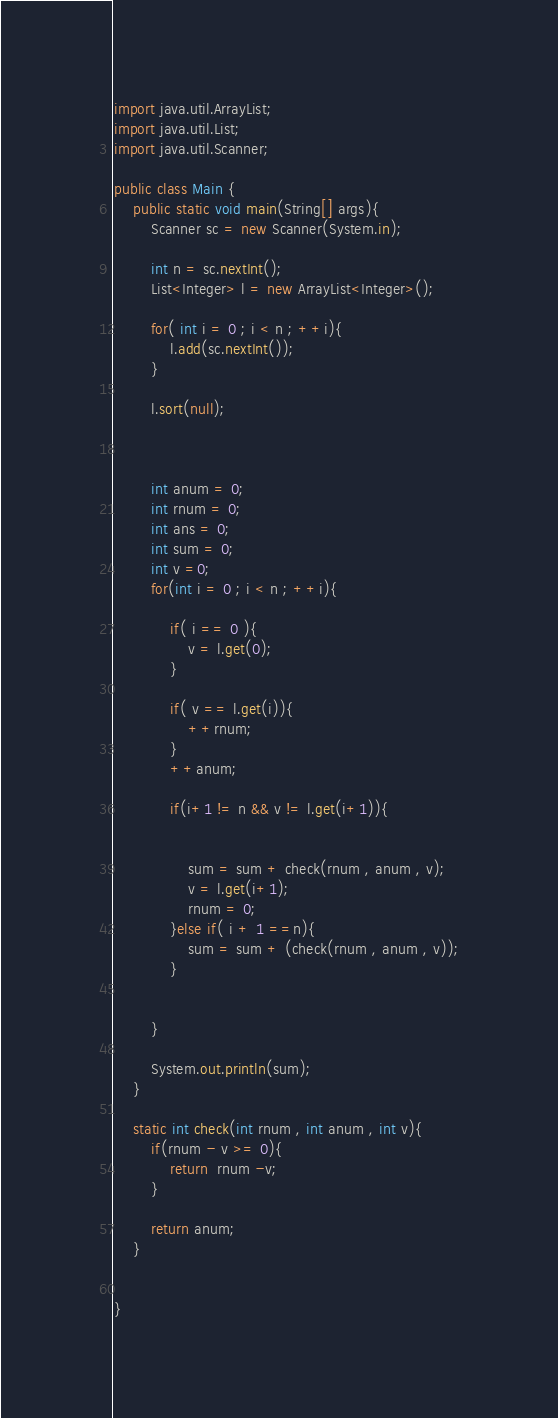<code> <loc_0><loc_0><loc_500><loc_500><_Java_>import java.util.ArrayList;
import java.util.List;
import java.util.Scanner;

public class Main {
	public static void main(String[] args){
		Scanner sc = new Scanner(System.in);

		int n = sc.nextInt();
		List<Integer> l = new ArrayList<Integer>();

		for( int i = 0 ; i < n ; ++i){
			l.add(sc.nextInt());
		}

		l.sort(null);



		int anum = 0;
		int rnum = 0;
		int ans = 0;
		int sum = 0;
		int v =0;
		for(int i = 0 ; i < n ; ++i){

			if( i == 0 ){
				v = l.get(0);
			}

			if( v == l.get(i)){
				++rnum;
			}
			++anum;

			if(i+1 != n && v != l.get(i+1)){


				sum = sum + check(rnum , anum , v);
				v = l.get(i+1);
				rnum = 0;
			}else if( i + 1 ==n){
				sum = sum + (check(rnum , anum , v));
			}


		}

		System.out.println(sum);
	}

	static int check(int rnum , int anum , int v){
		if(rnum - v >= 0){
			return  rnum -v;
		}
		
		return anum;
	}


}
</code> 